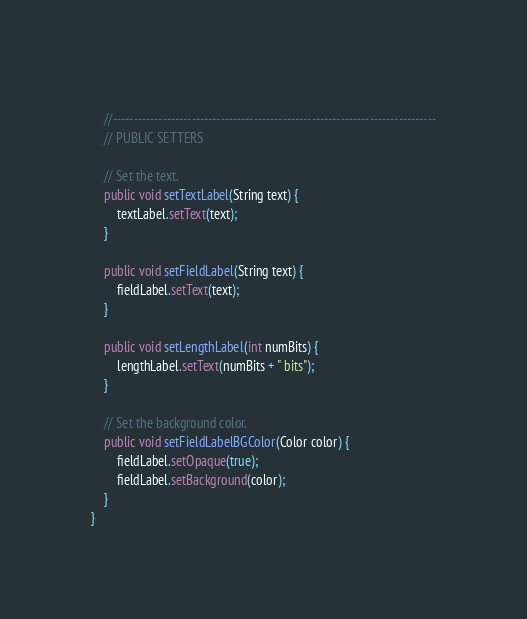<code> <loc_0><loc_0><loc_500><loc_500><_Java_>	
	//------------------------------------------------------------------------------
	// PUBLIC SETTERS
	
	// Set the text.
	public void setTextLabel(String text) {
		textLabel.setText(text);
	}
	
	public void setFieldLabel(String text) {
		fieldLabel.setText(text);
	}
	
	public void setLengthLabel(int numBits) {
		lengthLabel.setText(numBits + " bits");
	}
	
	// Set the background color.
	public void setFieldLabelBGColor(Color color) {
		fieldLabel.setOpaque(true);
		fieldLabel.setBackground(color);
	}
}
</code> 